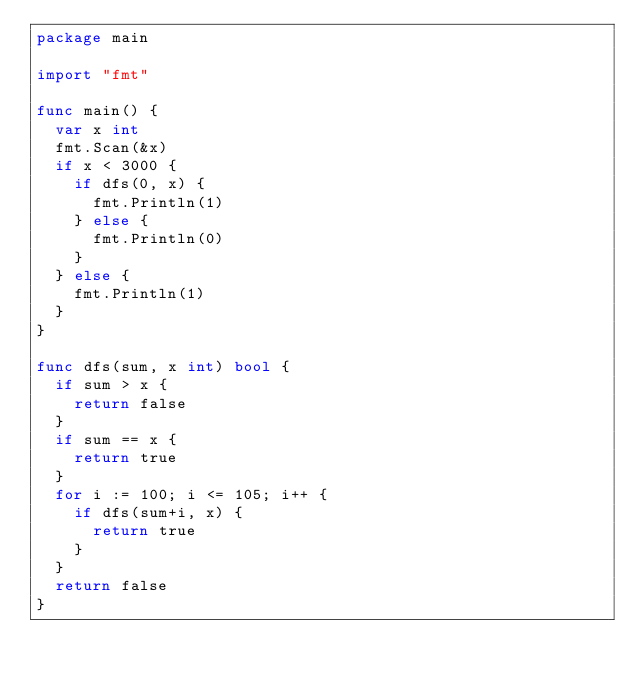<code> <loc_0><loc_0><loc_500><loc_500><_Go_>package main

import "fmt"

func main() {
	var x int
	fmt.Scan(&x)
	if x < 3000 {
		if dfs(0, x) {
			fmt.Println(1)
		} else {
			fmt.Println(0)
		}
	} else {
		fmt.Println(1)
	}
}

func dfs(sum, x int) bool {
	if sum > x {
		return false
	}
	if sum == x {
		return true
	}
	for i := 100; i <= 105; i++ {
		if dfs(sum+i, x) {
			return true
		}
	}
	return false
}
</code> 